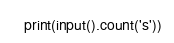<code> <loc_0><loc_0><loc_500><loc_500><_Python_>print(input().count('s'))</code> 